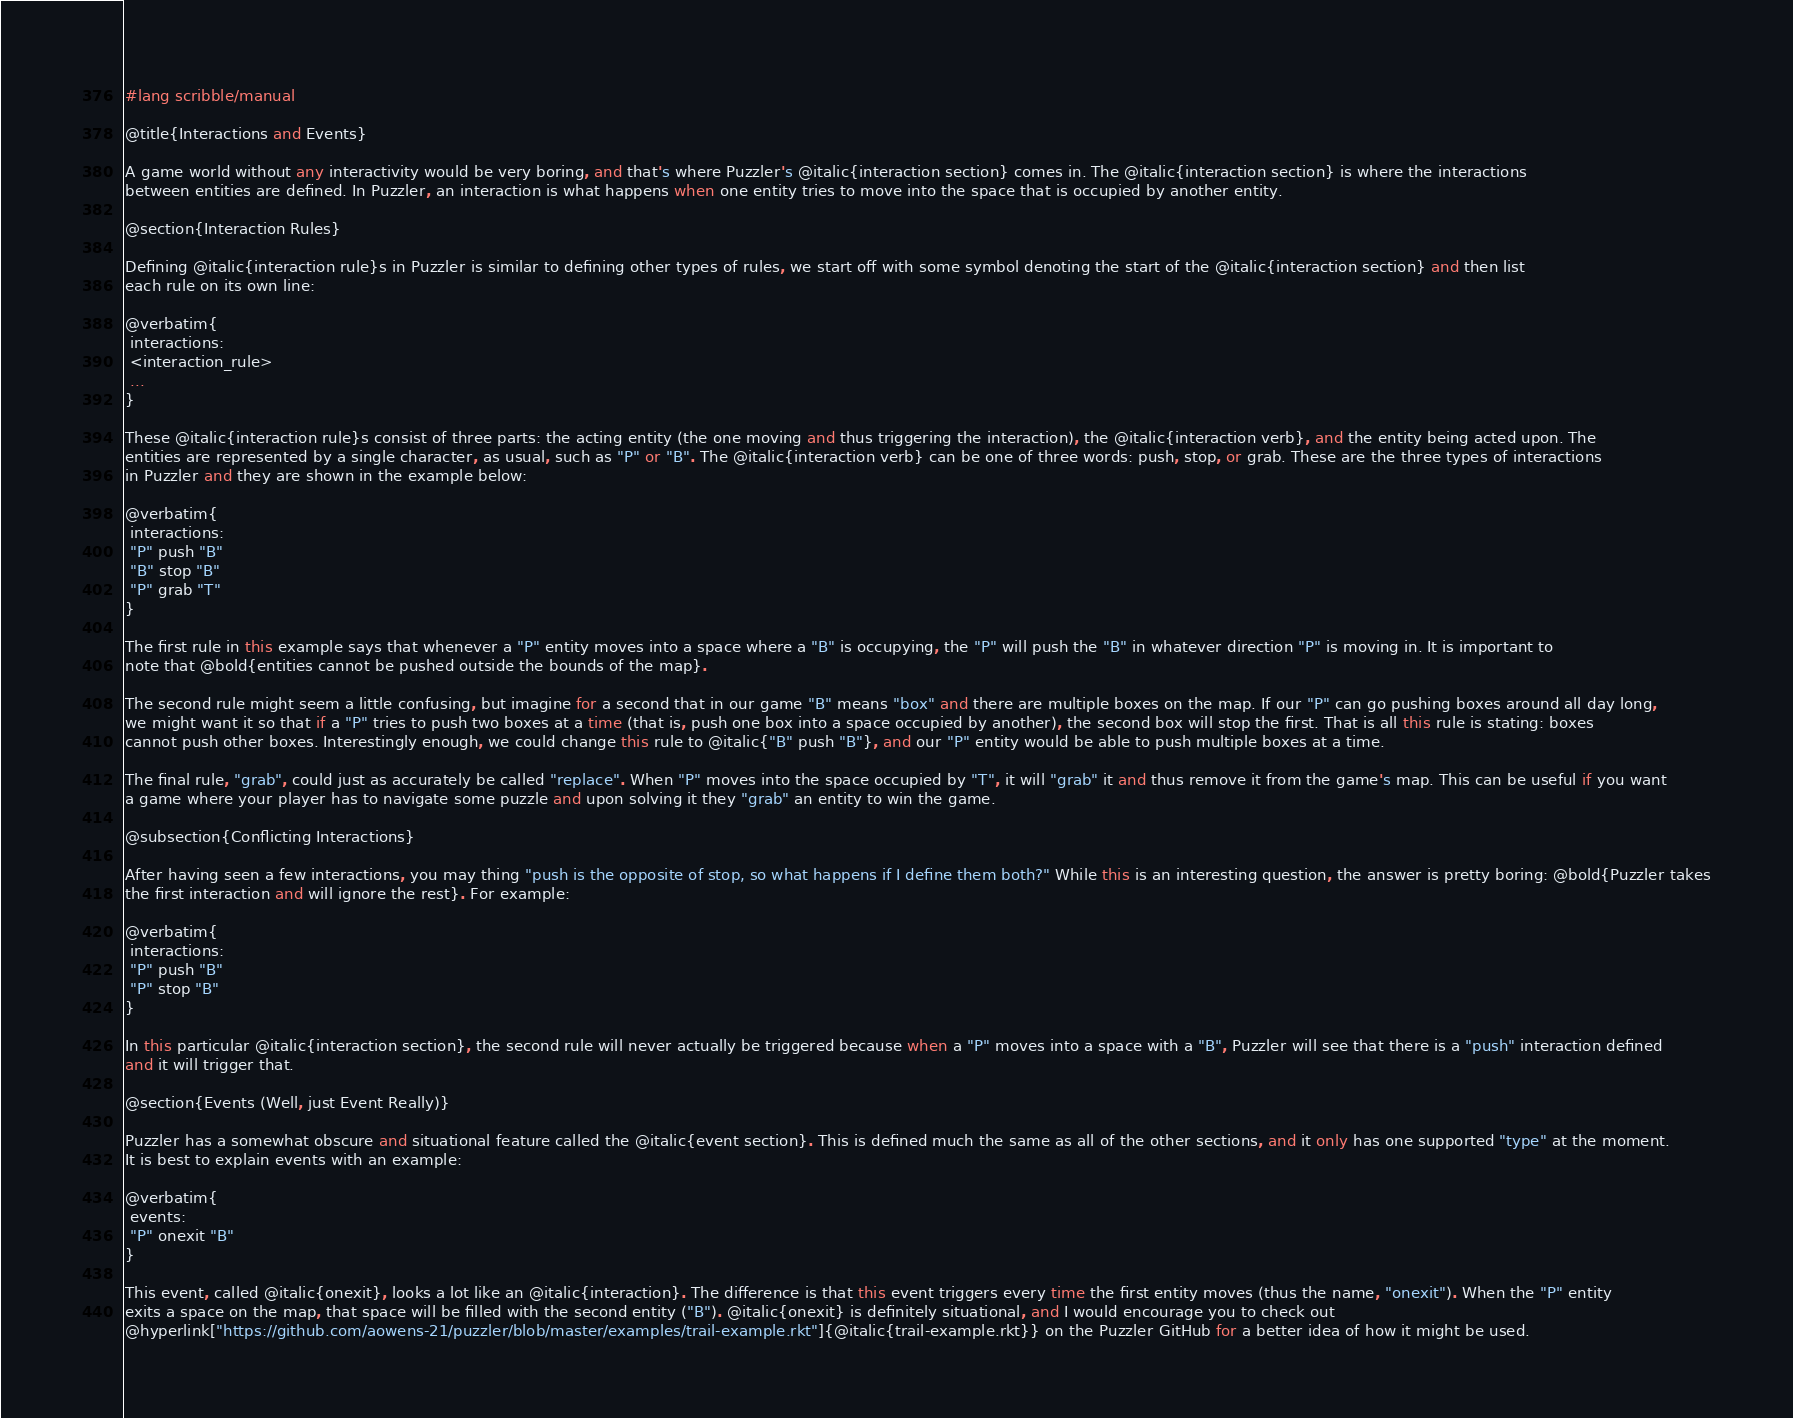<code> <loc_0><loc_0><loc_500><loc_500><_Racket_>#lang scribble/manual

@title{Interactions and Events}

A game world without any interactivity would be very boring, and that's where Puzzler's @italic{interaction section} comes in. The @italic{interaction section} is where the interactions
between entities are defined. In Puzzler, an interaction is what happens when one entity tries to move into the space that is occupied by another entity.

@section{Interaction Rules}

Defining @italic{interaction rule}s in Puzzler is similar to defining other types of rules, we start off with some symbol denoting the start of the @italic{interaction section} and then list
each rule on its own line:

@verbatim{
 interactions:
 <interaction_rule>
 ...
}

These @italic{interaction rule}s consist of three parts: the acting entity (the one moving and thus triggering the interaction), the @italic{interaction verb}, and the entity being acted upon. The
entities are represented by a single character, as usual, such as "P" or "B". The @italic{interaction verb} can be one of three words: push, stop, or grab. These are the three types of interactions
in Puzzler and they are shown in the example below:

@verbatim{
 interactions:
 "P" push "B"
 "B" stop "B"
 "P" grab "T"
}

The first rule in this example says that whenever a "P" entity moves into a space where a "B" is occupying, the "P" will push the "B" in whatever direction "P" is moving in. It is important to
note that @bold{entities cannot be pushed outside the bounds of the map}.

The second rule might seem a little confusing, but imagine for a second that in our game "B" means "box" and there are multiple boxes on the map. If our "P" can go pushing boxes around all day long,
we might want it so that if a "P" tries to push two boxes at a time (that is, push one box into a space occupied by another), the second box will stop the first. That is all this rule is stating: boxes
cannot push other boxes. Interestingly enough, we could change this rule to @italic{"B" push "B"}, and our "P" entity would be able to push multiple boxes at a time.

The final rule, "grab", could just as accurately be called "replace". When "P" moves into the space occupied by "T", it will "grab" it and thus remove it from the game's map. This can be useful if you want
a game where your player has to navigate some puzzle and upon solving it they "grab" an entity to win the game.

@subsection{Conflicting Interactions}

After having seen a few interactions, you may thing "push is the opposite of stop, so what happens if I define them both?" While this is an interesting question, the answer is pretty boring: @bold{Puzzler takes
the first interaction and will ignore the rest}. For example:

@verbatim{
 interactions:
 "P" push "B"
 "P" stop "B"
}

In this particular @italic{interaction section}, the second rule will never actually be triggered because when a "P" moves into a space with a "B", Puzzler will see that there is a "push" interaction defined
and it will trigger that.

@section{Events (Well, just Event Really)}

Puzzler has a somewhat obscure and situational feature called the @italic{event section}. This is defined much the same as all of the other sections, and it only has one supported "type" at the moment.
It is best to explain events with an example:

@verbatim{
 events:
 "P" onexit "B"
}

This event, called @italic{onexit}, looks a lot like an @italic{interaction}. The difference is that this event triggers every time the first entity moves (thus the name, "onexit"). When the "P" entity
exits a space on the map, that space will be filled with the second entity ("B"). @italic{onexit} is definitely situational, and I would encourage you to check out
@hyperlink["https://github.com/aowens-21/puzzler/blob/master/examples/trail-example.rkt"]{@italic{trail-example.rkt}} on the Puzzler GitHub for a better idea of how it might be used.

</code> 